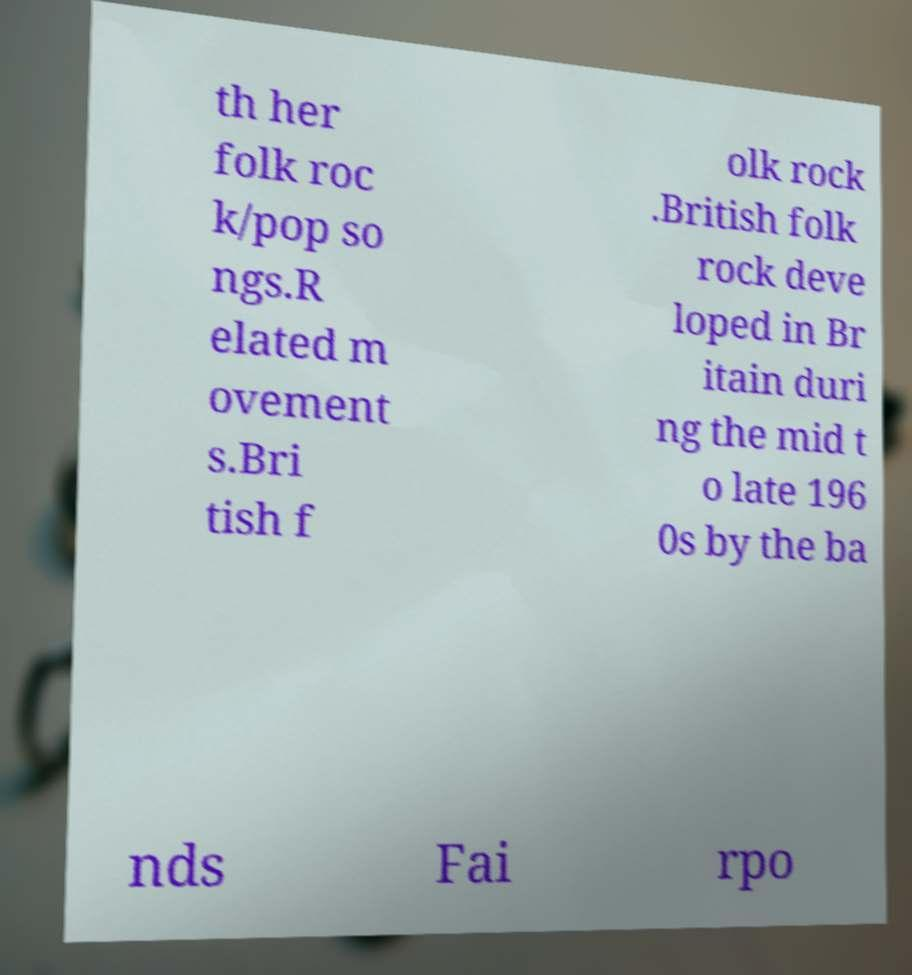Can you read and provide the text displayed in the image?This photo seems to have some interesting text. Can you extract and type it out for me? th her folk roc k/pop so ngs.R elated m ovement s.Bri tish f olk rock .British folk rock deve loped in Br itain duri ng the mid t o late 196 0s by the ba nds Fai rpo 